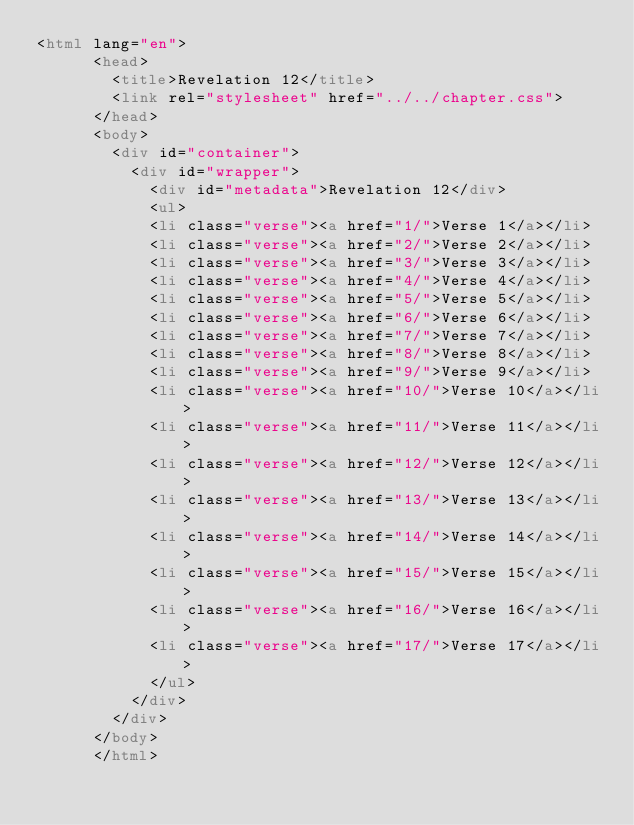Convert code to text. <code><loc_0><loc_0><loc_500><loc_500><_HTML_><html lang="en">
      <head>
        <title>Revelation 12</title>
        <link rel="stylesheet" href="../../chapter.css">
      </head>
      <body>
        <div id="container">
          <div id="wrapper">
            <div id="metadata">Revelation 12</div>
            <ul>
            <li class="verse"><a href="1/">Verse 1</a></li>
            <li class="verse"><a href="2/">Verse 2</a></li>
            <li class="verse"><a href="3/">Verse 3</a></li>
            <li class="verse"><a href="4/">Verse 4</a></li>
            <li class="verse"><a href="5/">Verse 5</a></li>
            <li class="verse"><a href="6/">Verse 6</a></li>
            <li class="verse"><a href="7/">Verse 7</a></li>
            <li class="verse"><a href="8/">Verse 8</a></li>
            <li class="verse"><a href="9/">Verse 9</a></li>
            <li class="verse"><a href="10/">Verse 10</a></li>
            <li class="verse"><a href="11/">Verse 11</a></li>
            <li class="verse"><a href="12/">Verse 12</a></li>
            <li class="verse"><a href="13/">Verse 13</a></li>
            <li class="verse"><a href="14/">Verse 14</a></li>
            <li class="verse"><a href="15/">Verse 15</a></li>
            <li class="verse"><a href="16/">Verse 16</a></li>
            <li class="verse"><a href="17/">Verse 17</a></li>
            </ul>
          </div>
        </div>
      </body>
      </html></code> 